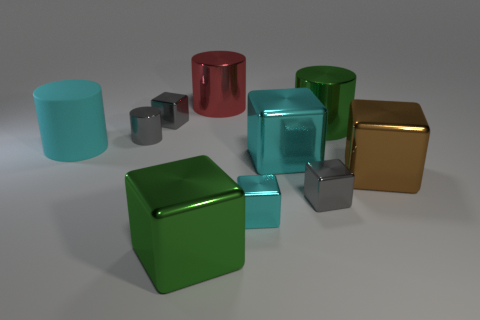Subtract all red metallic cylinders. How many cylinders are left? 3 Subtract all blue cylinders. How many gray cubes are left? 2 Subtract all green cubes. How many cubes are left? 5 Subtract 1 blocks. How many blocks are left? 5 Subtract all cylinders. How many objects are left? 6 Subtract all brown cylinders. Subtract all purple spheres. How many cylinders are left? 4 Add 7 large brown things. How many large brown things are left? 8 Add 10 tiny cyan rubber cylinders. How many tiny cyan rubber cylinders exist? 10 Subtract 0 brown cylinders. How many objects are left? 10 Subtract all large red rubber blocks. Subtract all small gray cylinders. How many objects are left? 9 